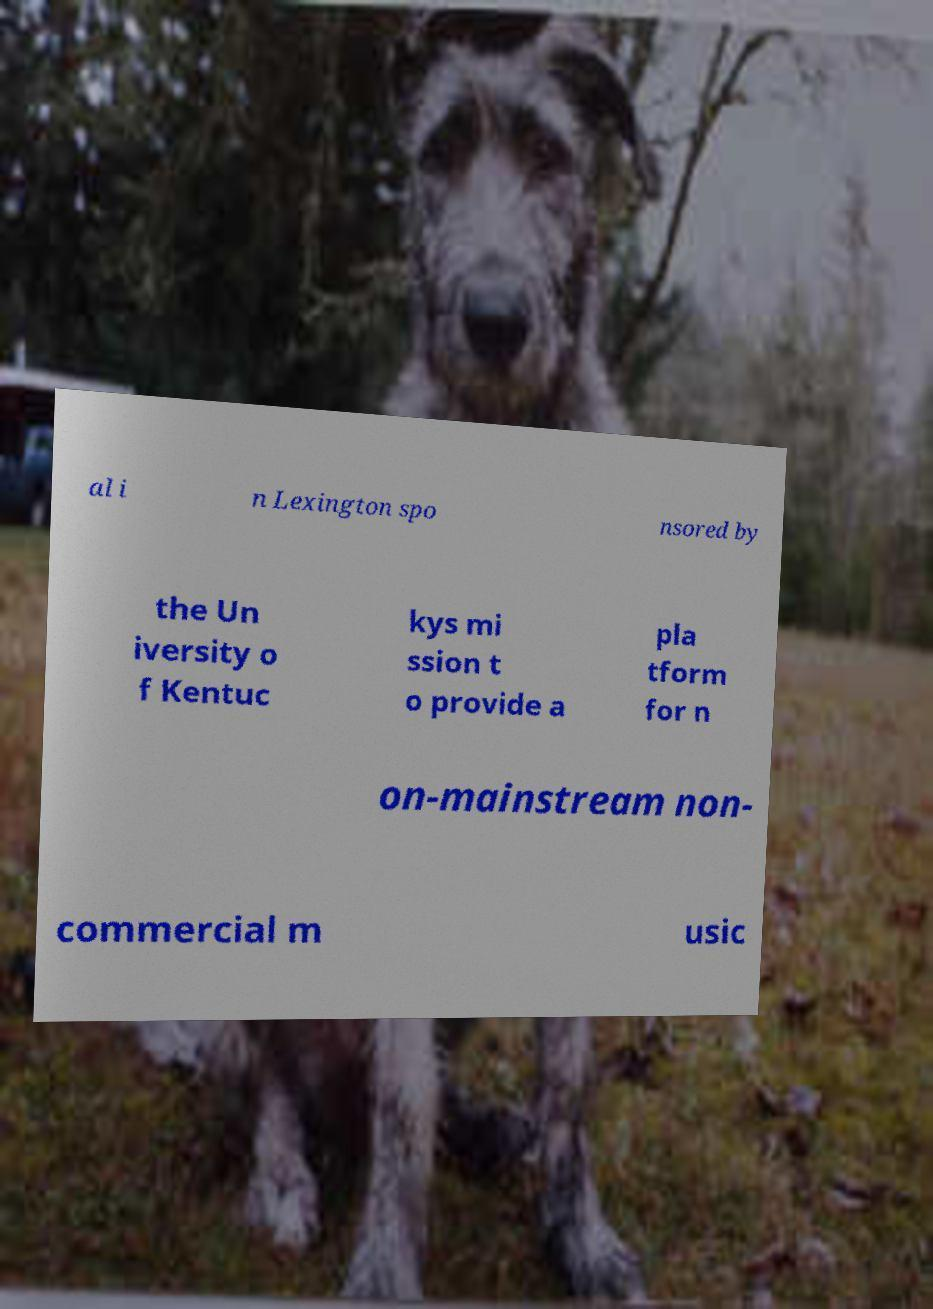For documentation purposes, I need the text within this image transcribed. Could you provide that? al i n Lexington spo nsored by the Un iversity o f Kentuc kys mi ssion t o provide a pla tform for n on-mainstream non- commercial m usic 